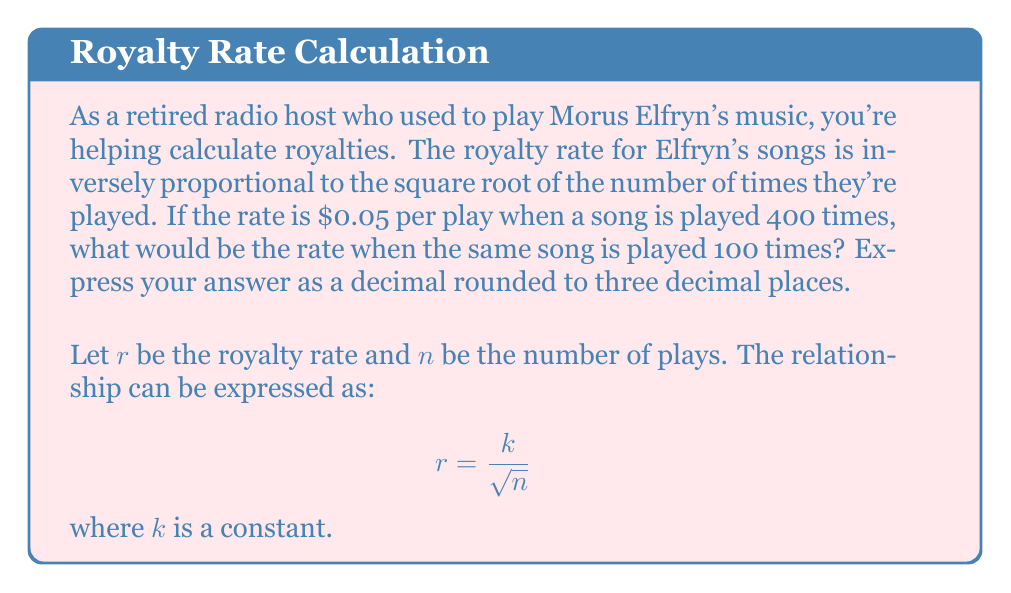Can you solve this math problem? Let's solve this step-by-step:

1) We know that the relationship between the royalty rate $(r)$ and number of plays $(n)$ is:

   $$r = \frac{k}{\sqrt{n}}$$

2) We're given that when $n = 400$, $r = 0.05$. Let's use this to find $k$:

   $$0.05 = \frac{k}{\sqrt{400}}$$

3) Simplify $\sqrt{400}$:

   $$0.05 = \frac{k}{20}$$

4) Solve for $k$:

   $$k = 0.05 \times 20 = 1$$

5) Now that we know $k = 1$, we can use this to find $r$ when $n = 100$:

   $$r = \frac{1}{\sqrt{100}}$$

6) Simplify $\sqrt{100}$:

   $$r = \frac{1}{10} = 0.1$$

Therefore, when the song is played 100 times, the royalty rate would be $0.1 or $0.100 when rounded to three decimal places.
Answer: $0.100 